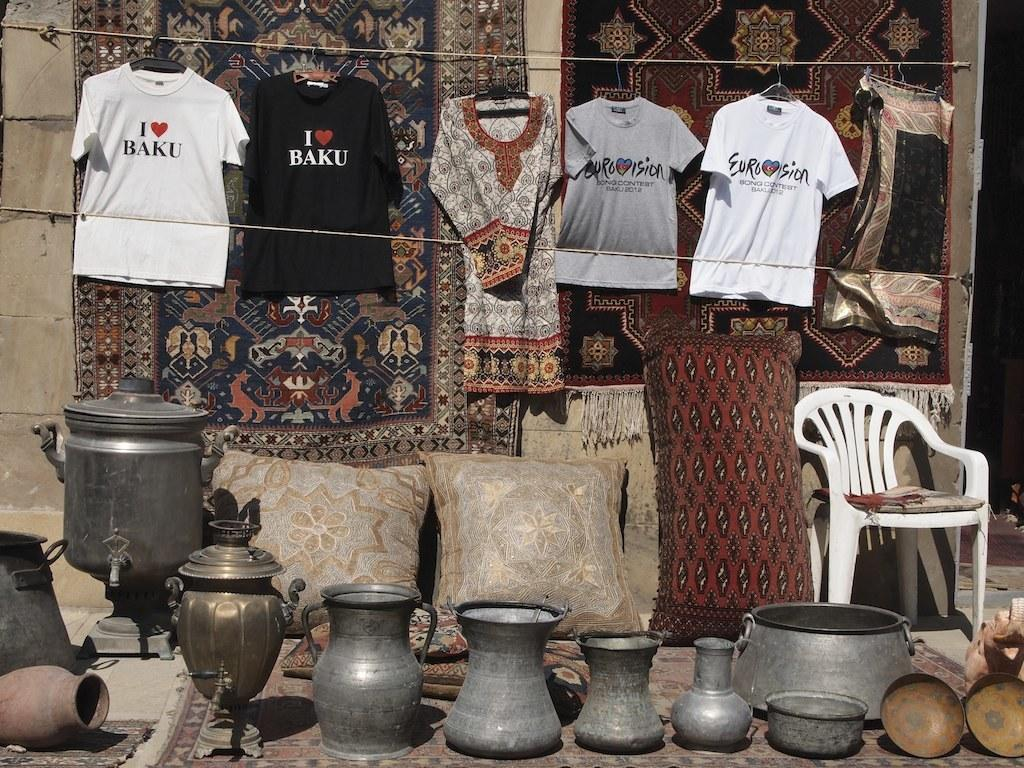Provide a one-sentence caption for the provided image. Metal vases, pillows, and t-shirts saying I LOVE BAKU and Eurovision hang for sale. 